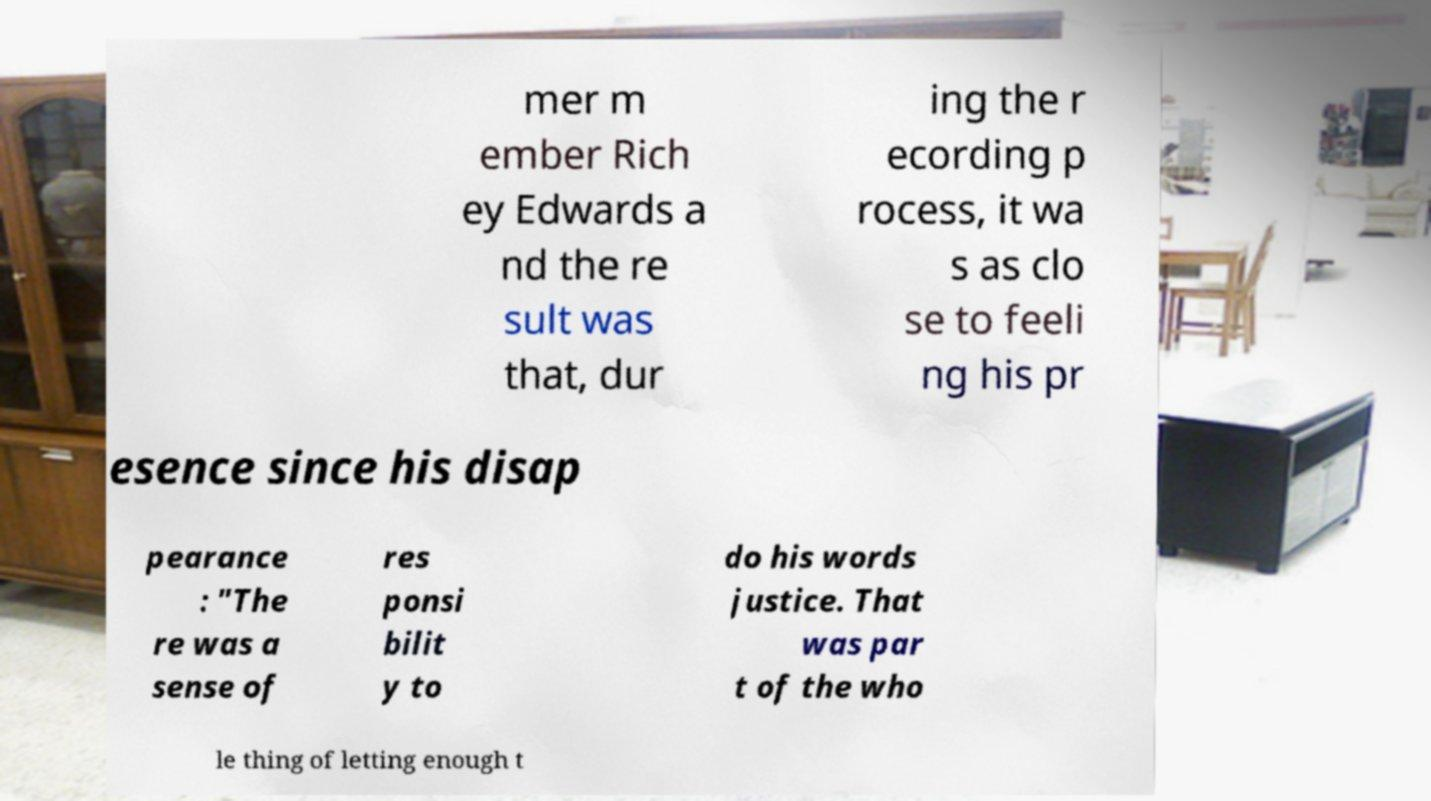Please read and relay the text visible in this image. What does it say? mer m ember Rich ey Edwards a nd the re sult was that, dur ing the r ecording p rocess, it wa s as clo se to feeli ng his pr esence since his disap pearance : "The re was a sense of res ponsi bilit y to do his words justice. That was par t of the who le thing of letting enough t 